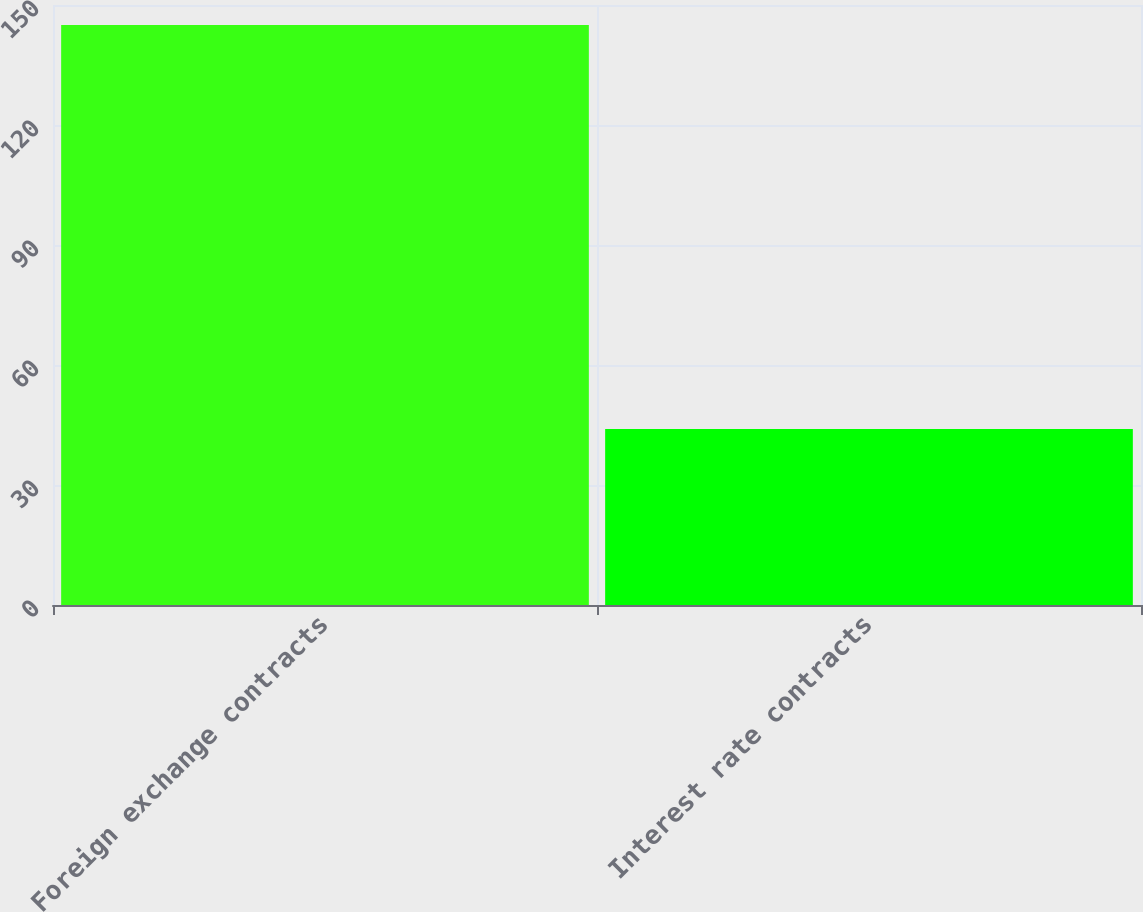<chart> <loc_0><loc_0><loc_500><loc_500><bar_chart><fcel>Foreign exchange contracts<fcel>Interest rate contracts<nl><fcel>145<fcel>44<nl></chart> 